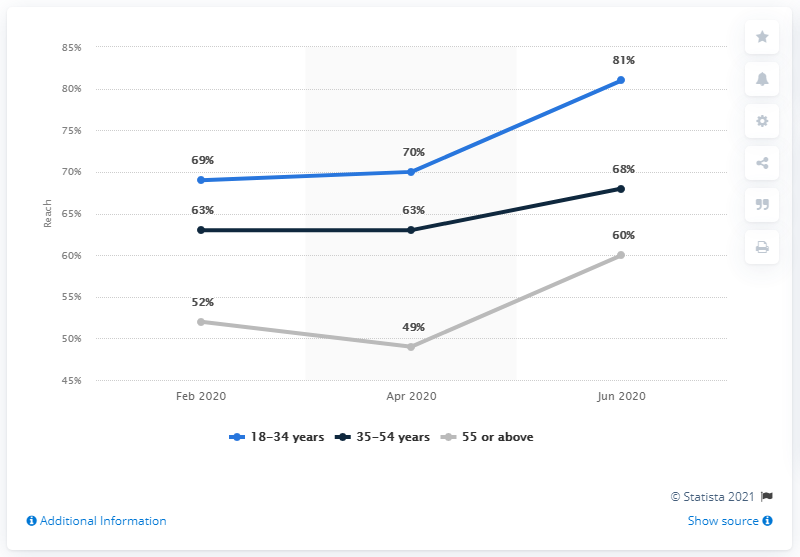List a handful of essential elements in this visual. In the light grey line chart for April 2020, the lowest percentage value is 49%. In June 2020, the highest percentage value in the blue line was 81%. In January 2020, 81% of adults aged 18 to 34 were Amazon Prime members. In February of 2020, Amazon Prime usage was 69. In January 2020, 81% of adults aged 18 to 34 were Amazon Prime members. 